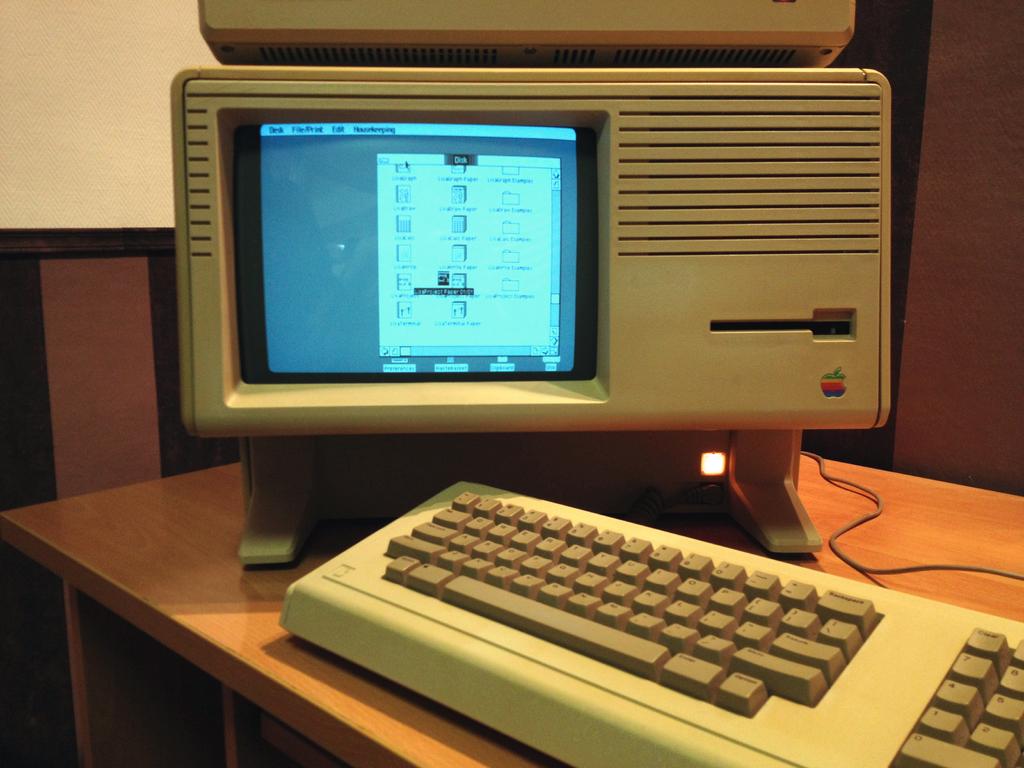What brand of computer is this?
Provide a succinct answer. Apple. What is the name of the window that is open on the computer?
Give a very brief answer. Disk. 